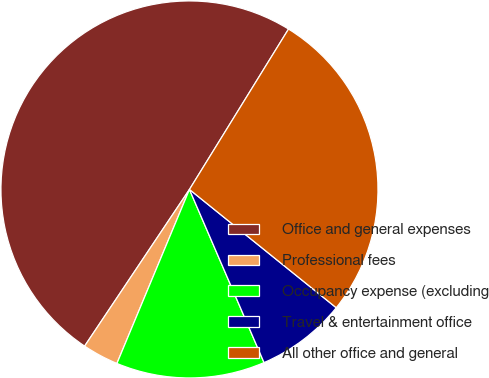Convert chart to OTSL. <chart><loc_0><loc_0><loc_500><loc_500><pie_chart><fcel>Office and general expenses<fcel>Professional fees<fcel>Occupancy expense (excluding<fcel>Travel & entertainment office<fcel>All other office and general<nl><fcel>49.42%<fcel>3.1%<fcel>12.76%<fcel>7.73%<fcel>26.99%<nl></chart> 